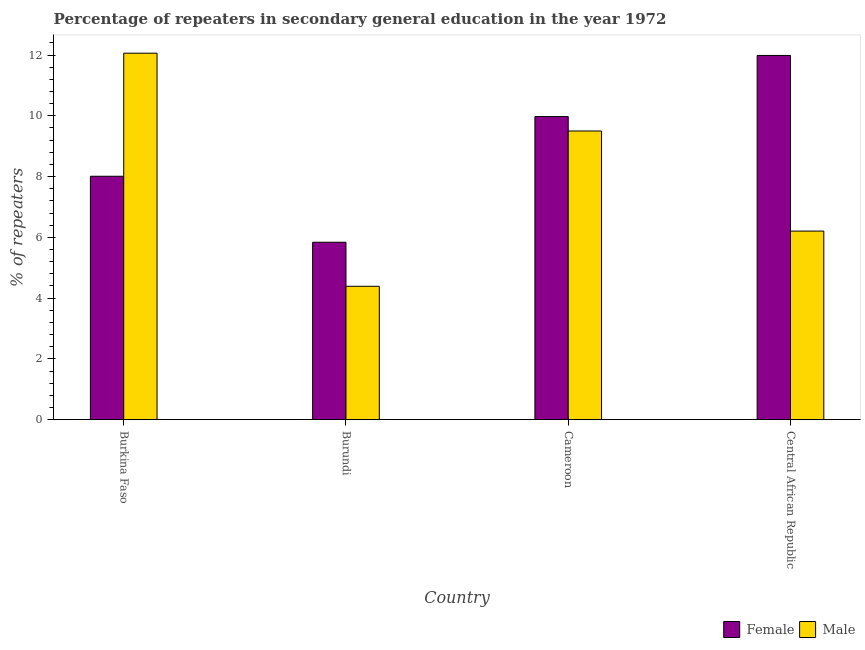How many groups of bars are there?
Your answer should be compact. 4. Are the number of bars per tick equal to the number of legend labels?
Your answer should be compact. Yes. Are the number of bars on each tick of the X-axis equal?
Offer a terse response. Yes. How many bars are there on the 4th tick from the left?
Keep it short and to the point. 2. What is the label of the 1st group of bars from the left?
Your answer should be very brief. Burkina Faso. In how many cases, is the number of bars for a given country not equal to the number of legend labels?
Offer a terse response. 0. What is the percentage of male repeaters in Central African Republic?
Provide a short and direct response. 6.21. Across all countries, what is the maximum percentage of male repeaters?
Provide a succinct answer. 12.06. Across all countries, what is the minimum percentage of male repeaters?
Keep it short and to the point. 4.39. In which country was the percentage of female repeaters maximum?
Your answer should be very brief. Central African Republic. In which country was the percentage of male repeaters minimum?
Give a very brief answer. Burundi. What is the total percentage of male repeaters in the graph?
Offer a very short reply. 32.16. What is the difference between the percentage of female repeaters in Burundi and that in Cameroon?
Provide a short and direct response. -4.13. What is the difference between the percentage of female repeaters in Burkina Faso and the percentage of male repeaters in Cameroon?
Your answer should be very brief. -1.49. What is the average percentage of male repeaters per country?
Offer a terse response. 8.04. What is the difference between the percentage of female repeaters and percentage of male repeaters in Burundi?
Provide a succinct answer. 1.45. What is the ratio of the percentage of male repeaters in Burkina Faso to that in Cameroon?
Keep it short and to the point. 1.27. Is the percentage of female repeaters in Burkina Faso less than that in Central African Republic?
Your response must be concise. Yes. What is the difference between the highest and the second highest percentage of male repeaters?
Provide a succinct answer. 2.56. What is the difference between the highest and the lowest percentage of female repeaters?
Your response must be concise. 6.15. In how many countries, is the percentage of female repeaters greater than the average percentage of female repeaters taken over all countries?
Your answer should be very brief. 2. Is the sum of the percentage of female repeaters in Cameroon and Central African Republic greater than the maximum percentage of male repeaters across all countries?
Give a very brief answer. Yes. What does the 1st bar from the left in Burundi represents?
Ensure brevity in your answer.  Female. What does the 2nd bar from the right in Burundi represents?
Ensure brevity in your answer.  Female. What is the difference between two consecutive major ticks on the Y-axis?
Your response must be concise. 2. Are the values on the major ticks of Y-axis written in scientific E-notation?
Offer a very short reply. No. Does the graph contain any zero values?
Your answer should be very brief. No. Does the graph contain grids?
Give a very brief answer. No. Where does the legend appear in the graph?
Your response must be concise. Bottom right. How many legend labels are there?
Your answer should be compact. 2. How are the legend labels stacked?
Make the answer very short. Horizontal. What is the title of the graph?
Provide a short and direct response. Percentage of repeaters in secondary general education in the year 1972. Does "Netherlands" appear as one of the legend labels in the graph?
Keep it short and to the point. No. What is the label or title of the X-axis?
Provide a short and direct response. Country. What is the label or title of the Y-axis?
Provide a succinct answer. % of repeaters. What is the % of repeaters in Female in Burkina Faso?
Provide a succinct answer. 8.01. What is the % of repeaters in Male in Burkina Faso?
Your response must be concise. 12.06. What is the % of repeaters in Female in Burundi?
Make the answer very short. 5.84. What is the % of repeaters of Male in Burundi?
Your answer should be compact. 4.39. What is the % of repeaters in Female in Cameroon?
Your answer should be compact. 9.97. What is the % of repeaters in Male in Cameroon?
Provide a short and direct response. 9.5. What is the % of repeaters in Female in Central African Republic?
Give a very brief answer. 11.99. What is the % of repeaters in Male in Central African Republic?
Offer a very short reply. 6.21. Across all countries, what is the maximum % of repeaters of Female?
Ensure brevity in your answer.  11.99. Across all countries, what is the maximum % of repeaters in Male?
Your answer should be compact. 12.06. Across all countries, what is the minimum % of repeaters in Female?
Your response must be concise. 5.84. Across all countries, what is the minimum % of repeaters in Male?
Keep it short and to the point. 4.39. What is the total % of repeaters in Female in the graph?
Provide a short and direct response. 35.81. What is the total % of repeaters of Male in the graph?
Your answer should be very brief. 32.16. What is the difference between the % of repeaters of Female in Burkina Faso and that in Burundi?
Offer a terse response. 2.17. What is the difference between the % of repeaters in Male in Burkina Faso and that in Burundi?
Provide a succinct answer. 7.67. What is the difference between the % of repeaters of Female in Burkina Faso and that in Cameroon?
Provide a short and direct response. -1.96. What is the difference between the % of repeaters in Male in Burkina Faso and that in Cameroon?
Your response must be concise. 2.56. What is the difference between the % of repeaters of Female in Burkina Faso and that in Central African Republic?
Provide a short and direct response. -3.98. What is the difference between the % of repeaters of Male in Burkina Faso and that in Central African Republic?
Offer a terse response. 5.85. What is the difference between the % of repeaters of Female in Burundi and that in Cameroon?
Offer a terse response. -4.13. What is the difference between the % of repeaters in Male in Burundi and that in Cameroon?
Offer a very short reply. -5.11. What is the difference between the % of repeaters in Female in Burundi and that in Central African Republic?
Your answer should be compact. -6.15. What is the difference between the % of repeaters in Male in Burundi and that in Central African Republic?
Your response must be concise. -1.82. What is the difference between the % of repeaters of Female in Cameroon and that in Central African Republic?
Offer a very short reply. -2.01. What is the difference between the % of repeaters of Male in Cameroon and that in Central African Republic?
Ensure brevity in your answer.  3.29. What is the difference between the % of repeaters in Female in Burkina Faso and the % of repeaters in Male in Burundi?
Your answer should be very brief. 3.62. What is the difference between the % of repeaters of Female in Burkina Faso and the % of repeaters of Male in Cameroon?
Your answer should be very brief. -1.49. What is the difference between the % of repeaters in Female in Burkina Faso and the % of repeaters in Male in Central African Republic?
Your response must be concise. 1.8. What is the difference between the % of repeaters of Female in Burundi and the % of repeaters of Male in Cameroon?
Your answer should be very brief. -3.66. What is the difference between the % of repeaters of Female in Burundi and the % of repeaters of Male in Central African Republic?
Offer a terse response. -0.37. What is the difference between the % of repeaters of Female in Cameroon and the % of repeaters of Male in Central African Republic?
Your answer should be very brief. 3.77. What is the average % of repeaters of Female per country?
Make the answer very short. 8.95. What is the average % of repeaters in Male per country?
Provide a short and direct response. 8.04. What is the difference between the % of repeaters in Female and % of repeaters in Male in Burkina Faso?
Make the answer very short. -4.05. What is the difference between the % of repeaters in Female and % of repeaters in Male in Burundi?
Keep it short and to the point. 1.45. What is the difference between the % of repeaters in Female and % of repeaters in Male in Cameroon?
Offer a terse response. 0.47. What is the difference between the % of repeaters in Female and % of repeaters in Male in Central African Republic?
Your response must be concise. 5.78. What is the ratio of the % of repeaters in Female in Burkina Faso to that in Burundi?
Keep it short and to the point. 1.37. What is the ratio of the % of repeaters in Male in Burkina Faso to that in Burundi?
Your response must be concise. 2.75. What is the ratio of the % of repeaters in Female in Burkina Faso to that in Cameroon?
Make the answer very short. 0.8. What is the ratio of the % of repeaters in Male in Burkina Faso to that in Cameroon?
Your answer should be compact. 1.27. What is the ratio of the % of repeaters of Female in Burkina Faso to that in Central African Republic?
Your response must be concise. 0.67. What is the ratio of the % of repeaters of Male in Burkina Faso to that in Central African Republic?
Your answer should be compact. 1.94. What is the ratio of the % of repeaters of Female in Burundi to that in Cameroon?
Your answer should be very brief. 0.59. What is the ratio of the % of repeaters of Male in Burundi to that in Cameroon?
Provide a succinct answer. 0.46. What is the ratio of the % of repeaters in Female in Burundi to that in Central African Republic?
Your response must be concise. 0.49. What is the ratio of the % of repeaters of Male in Burundi to that in Central African Republic?
Ensure brevity in your answer.  0.71. What is the ratio of the % of repeaters in Female in Cameroon to that in Central African Republic?
Your answer should be very brief. 0.83. What is the ratio of the % of repeaters of Male in Cameroon to that in Central African Republic?
Make the answer very short. 1.53. What is the difference between the highest and the second highest % of repeaters in Female?
Provide a succinct answer. 2.01. What is the difference between the highest and the second highest % of repeaters in Male?
Your answer should be very brief. 2.56. What is the difference between the highest and the lowest % of repeaters in Female?
Ensure brevity in your answer.  6.15. What is the difference between the highest and the lowest % of repeaters of Male?
Your response must be concise. 7.67. 